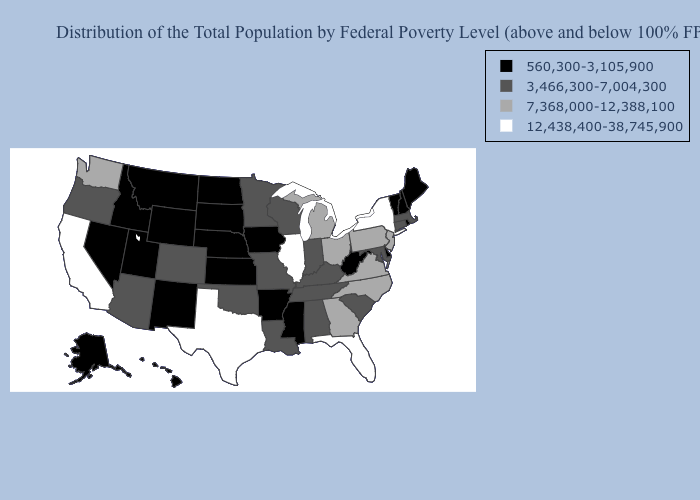What is the value of North Dakota?
Be succinct. 560,300-3,105,900. Among the states that border Arkansas , does Mississippi have the lowest value?
Answer briefly. Yes. Does Iowa have the same value as North Dakota?
Keep it brief. Yes. Name the states that have a value in the range 12,438,400-38,745,900?
Concise answer only. California, Florida, Illinois, New York, Texas. Which states hav the highest value in the MidWest?
Give a very brief answer. Illinois. What is the value of Oregon?
Answer briefly. 3,466,300-7,004,300. What is the value of Hawaii?
Keep it brief. 560,300-3,105,900. Does the map have missing data?
Give a very brief answer. No. Does Nebraska have a lower value than Minnesota?
Write a very short answer. Yes. What is the value of Rhode Island?
Write a very short answer. 560,300-3,105,900. What is the lowest value in the USA?
Be succinct. 560,300-3,105,900. What is the highest value in the USA?
Write a very short answer. 12,438,400-38,745,900. What is the lowest value in the USA?
Write a very short answer. 560,300-3,105,900. Does New Hampshire have the lowest value in the Northeast?
Give a very brief answer. Yes. How many symbols are there in the legend?
Concise answer only. 4. 